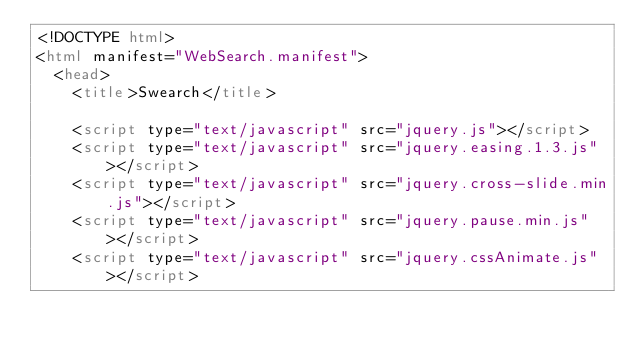<code> <loc_0><loc_0><loc_500><loc_500><_HTML_><!DOCTYPE html>
<html manifest="WebSearch.manifest">
	<head>
		<title>Swearch</title>

		<script type="text/javascript" src="jquery.js"></script>
		<script type="text/javascript" src="jquery.easing.1.3.js"></script>
		<script type="text/javascript" src="jquery.cross-slide.min.js"></script>
		<script type="text/javascript" src="jquery.pause.min.js"></script>
		<script type="text/javascript" src="jquery.cssAnimate.js"></script></code> 